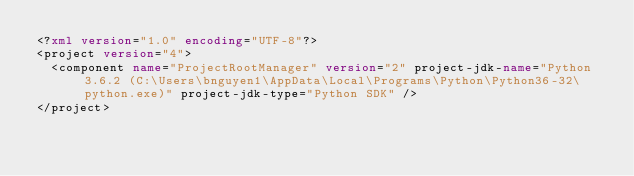Convert code to text. <code><loc_0><loc_0><loc_500><loc_500><_XML_><?xml version="1.0" encoding="UTF-8"?>
<project version="4">
  <component name="ProjectRootManager" version="2" project-jdk-name="Python 3.6.2 (C:\Users\bnguyen1\AppData\Local\Programs\Python\Python36-32\python.exe)" project-jdk-type="Python SDK" />
</project></code> 